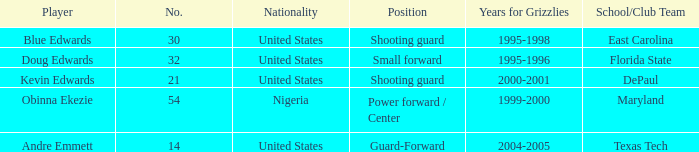Which position did kevin edwards play for Shooting guard. 